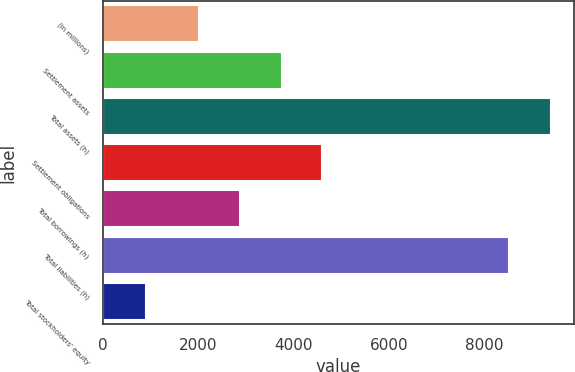<chart> <loc_0><loc_0><loc_500><loc_500><bar_chart><fcel>(in millions)<fcel>Settlement assets<fcel>Total assets (h)<fcel>Settlement obligations<fcel>Total borrowings (h)<fcel>Total liabilities (h)<fcel>Total stockholders' equity<nl><fcel>2016<fcel>3749.1<fcel>9419.6<fcel>4600.84<fcel>2867.74<fcel>8517.4<fcel>902.2<nl></chart> 